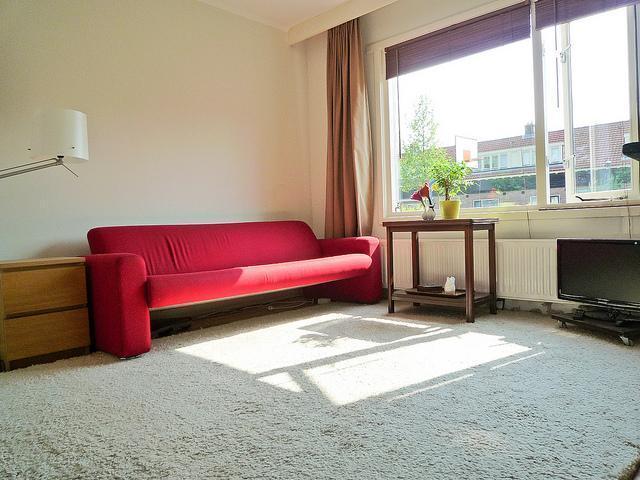How many potted plants can be seen?
Give a very brief answer. 1. 